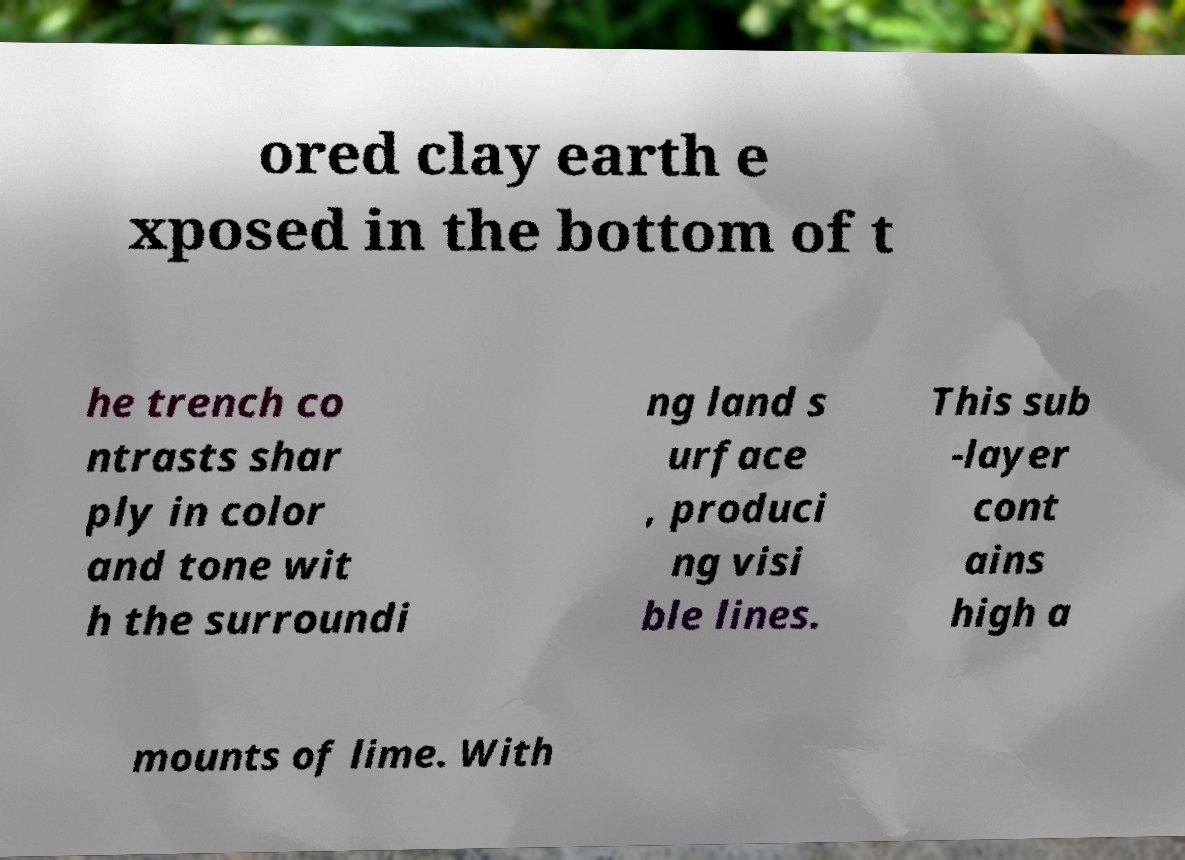For documentation purposes, I need the text within this image transcribed. Could you provide that? ored clay earth e xposed in the bottom of t he trench co ntrasts shar ply in color and tone wit h the surroundi ng land s urface , produci ng visi ble lines. This sub -layer cont ains high a mounts of lime. With 